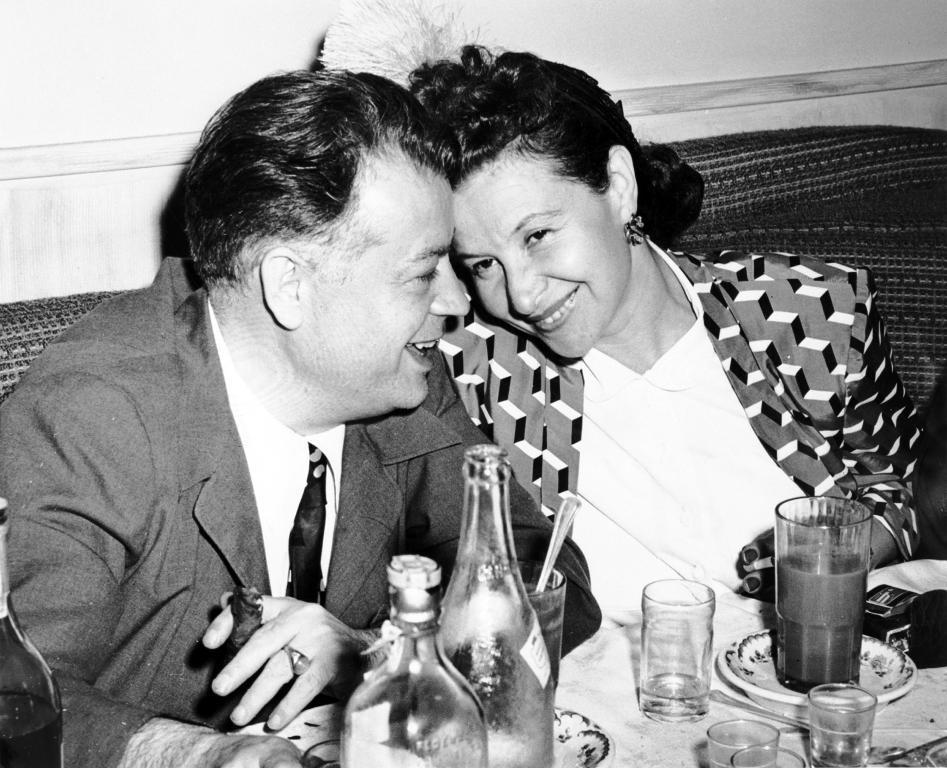Can you describe this image briefly? In the center of the image there is a man and woman sitting on the sofa. At the bottom of the image we can see bottles, glasses, beverage, plate placed on the table. In the background there is wall. 